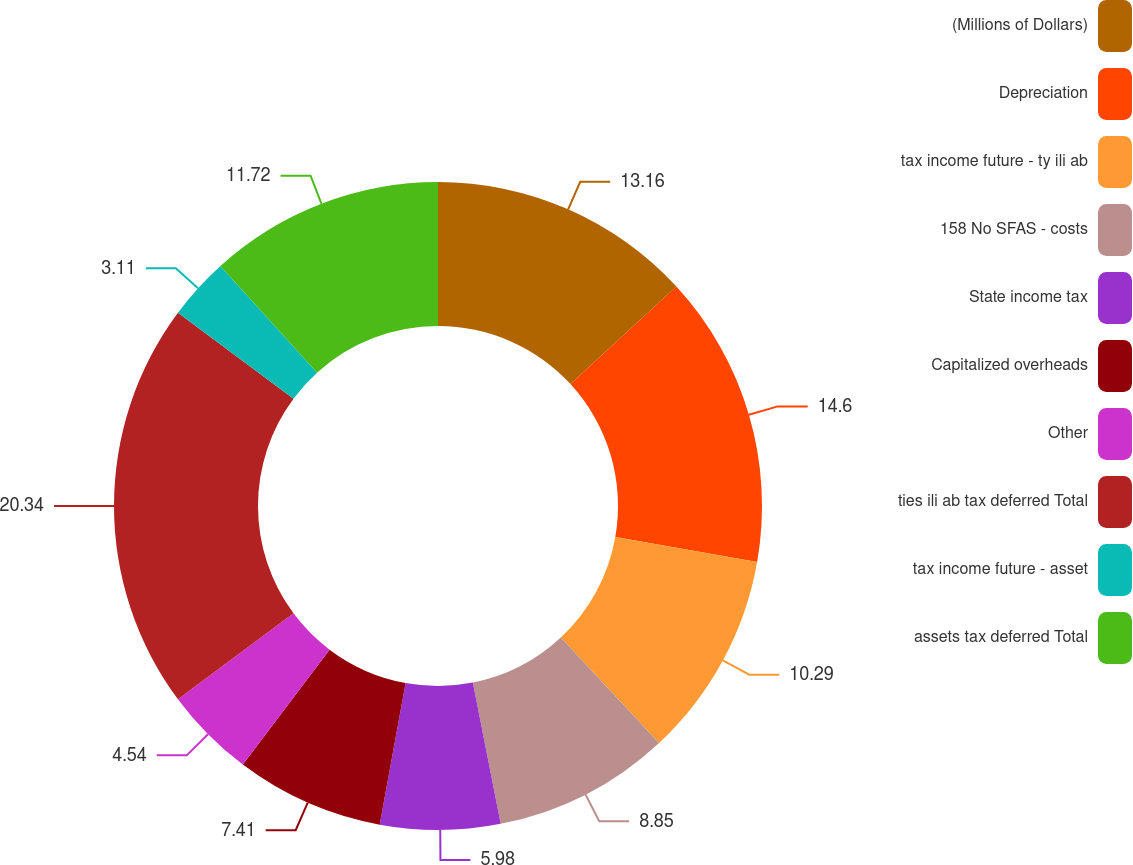<chart> <loc_0><loc_0><loc_500><loc_500><pie_chart><fcel>(Millions of Dollars)<fcel>Depreciation<fcel>tax income future - ty ili ab<fcel>158 No SFAS - costs<fcel>State income tax<fcel>Capitalized overheads<fcel>Other<fcel>ties ili ab tax deferred Total<fcel>tax income future - asset<fcel>assets tax deferred Total<nl><fcel>13.16%<fcel>14.6%<fcel>10.29%<fcel>8.85%<fcel>5.98%<fcel>7.41%<fcel>4.54%<fcel>20.34%<fcel>3.11%<fcel>11.72%<nl></chart> 